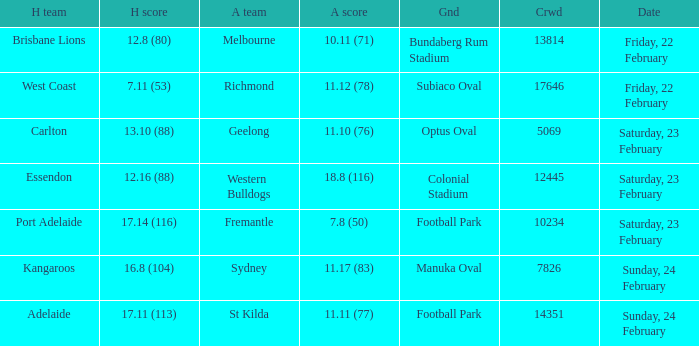On what date did the away team Fremantle play? Saturday, 23 February. 